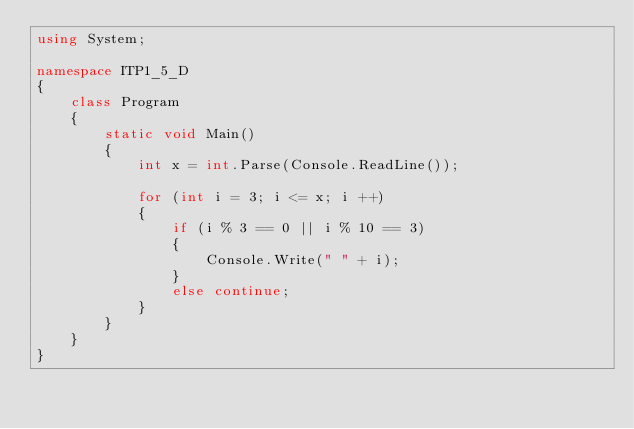<code> <loc_0><loc_0><loc_500><loc_500><_C#_>using System;

namespace ITP1_5_D
{
    class Program
    {
        static void Main()
        {
            int x = int.Parse(Console.ReadLine());
            
            for (int i = 3; i <= x; i ++)
            {
                if (i % 3 == 0 || i % 10 == 3)
                {
                    Console.Write(" " + i);
                }
                else continue;
            }
        }
    }
}
</code> 